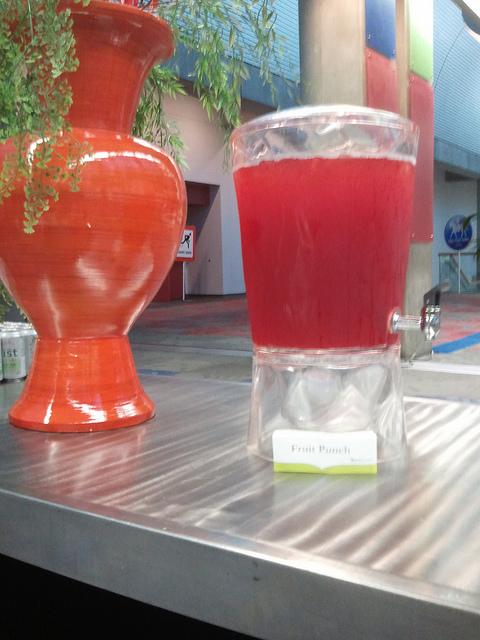How much liquid is in that container?
Concise answer only. 1 gallon. What is the glass sitting on?
Keep it brief. Counter. Is this vase on display?
Give a very brief answer. Yes. What color is the vase?
Give a very brief answer. Orange. 